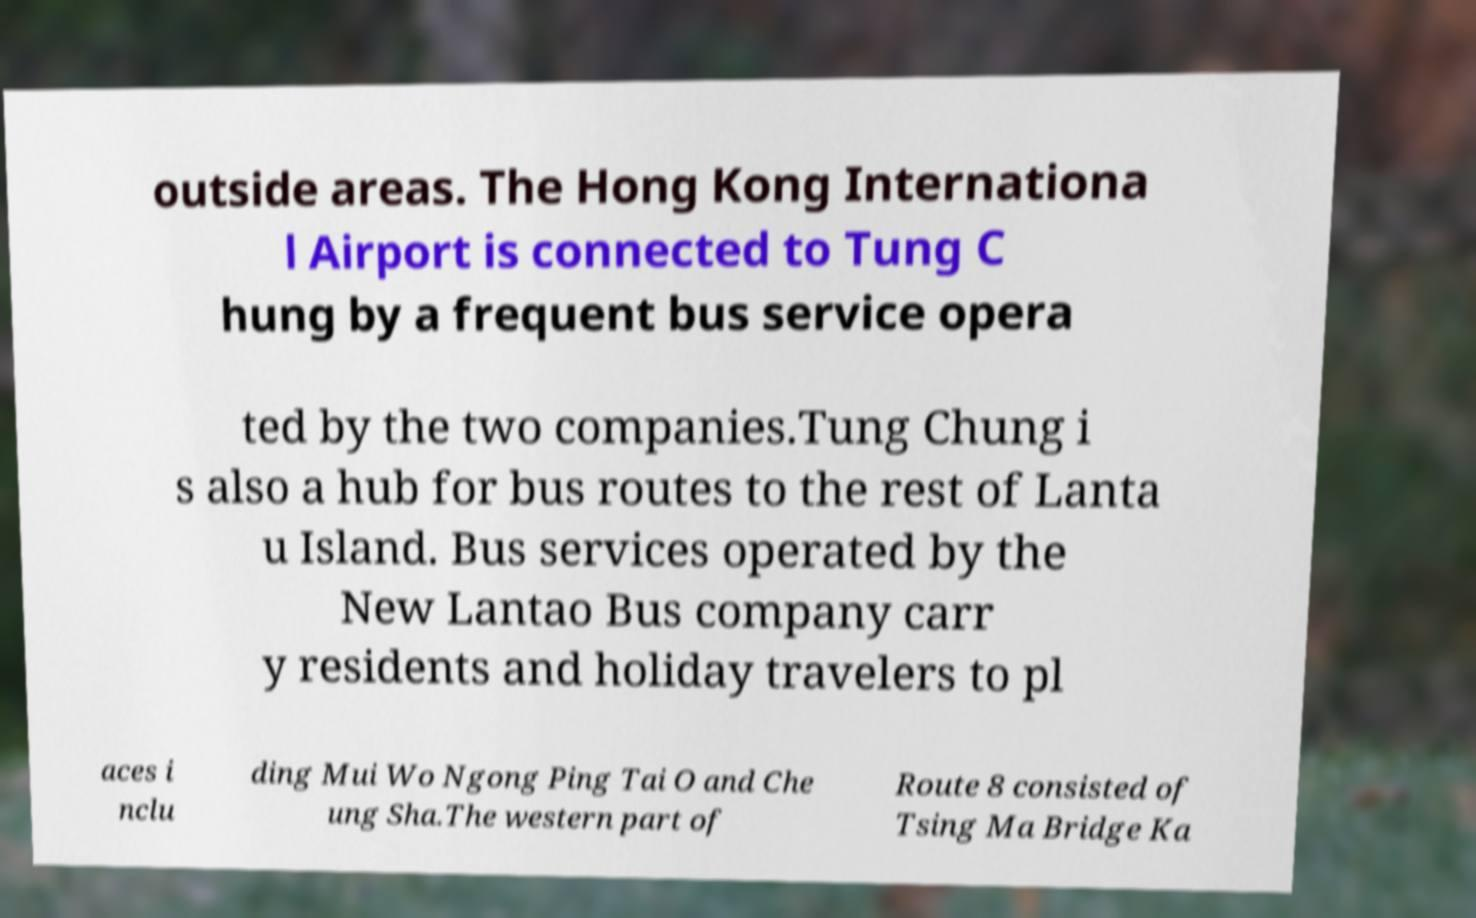Please identify and transcribe the text found in this image. outside areas. The Hong Kong Internationa l Airport is connected to Tung C hung by a frequent bus service opera ted by the two companies.Tung Chung i s also a hub for bus routes to the rest of Lanta u Island. Bus services operated by the New Lantao Bus company carr y residents and holiday travelers to pl aces i nclu ding Mui Wo Ngong Ping Tai O and Che ung Sha.The western part of Route 8 consisted of Tsing Ma Bridge Ka 